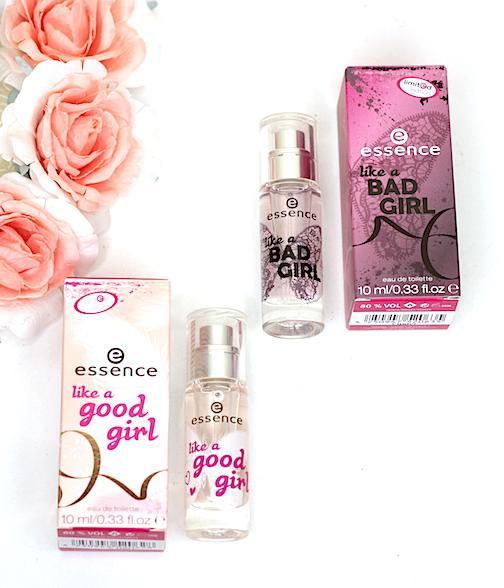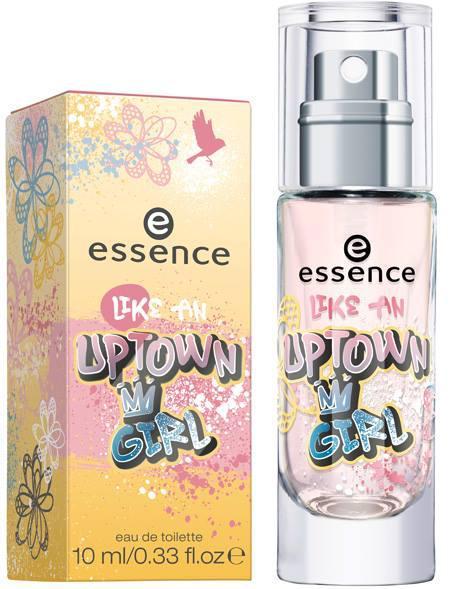The first image is the image on the left, the second image is the image on the right. For the images displayed, is the sentence "one of the perfume bottles has a ribbon on its neck." factually correct? Answer yes or no. No. 